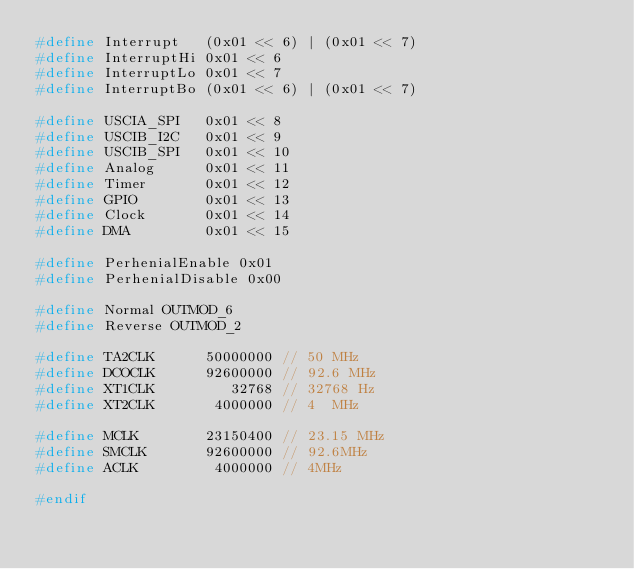<code> <loc_0><loc_0><loc_500><loc_500><_C_>#define Interrupt   (0x01 << 6) | (0x01 << 7)
#define InterruptHi 0x01 << 6
#define InterruptLo 0x01 << 7
#define InterruptBo (0x01 << 6) | (0x01 << 7)

#define USCIA_SPI   0x01 << 8
#define USCIB_I2C   0x01 << 9
#define USCIB_SPI   0x01 << 10
#define Analog      0x01 << 11
#define Timer       0x01 << 12
#define GPIO        0x01 << 13
#define Clock       0x01 << 14
#define DMA         0x01 << 15

#define PerhenialEnable 0x01
#define PerhenialDisable 0x00

#define Normal OUTMOD_6
#define Reverse OUTMOD_2

#define TA2CLK      50000000 // 50 MHz
#define DCOCLK      92600000 // 92.6 MHz
#define XT1CLK         32768 // 32768 Hz
#define XT2CLK       4000000 // 4  MHz

#define MCLK        23150400 // 23.15 MHz
#define SMCLK       92600000 // 92.6MHz
#define ACLK         4000000 // 4MHz

#endif</code> 